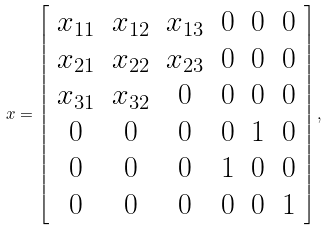<formula> <loc_0><loc_0><loc_500><loc_500>x = \left [ \begin{array} { c c c c c c } x _ { 1 1 } & x _ { 1 2 } & x _ { 1 3 } & 0 & 0 & 0 \\ x _ { 2 1 } & x _ { 2 2 } & x _ { 2 3 } & 0 & 0 & 0 \\ x _ { 3 1 } & x _ { 3 2 } & 0 & 0 & 0 & 0 \\ 0 & 0 & 0 & 0 & 1 & 0 \\ 0 & 0 & 0 & 1 & 0 & 0 \\ 0 & 0 & 0 & 0 & 0 & 1 \\ \end{array} \right ] ,</formula> 